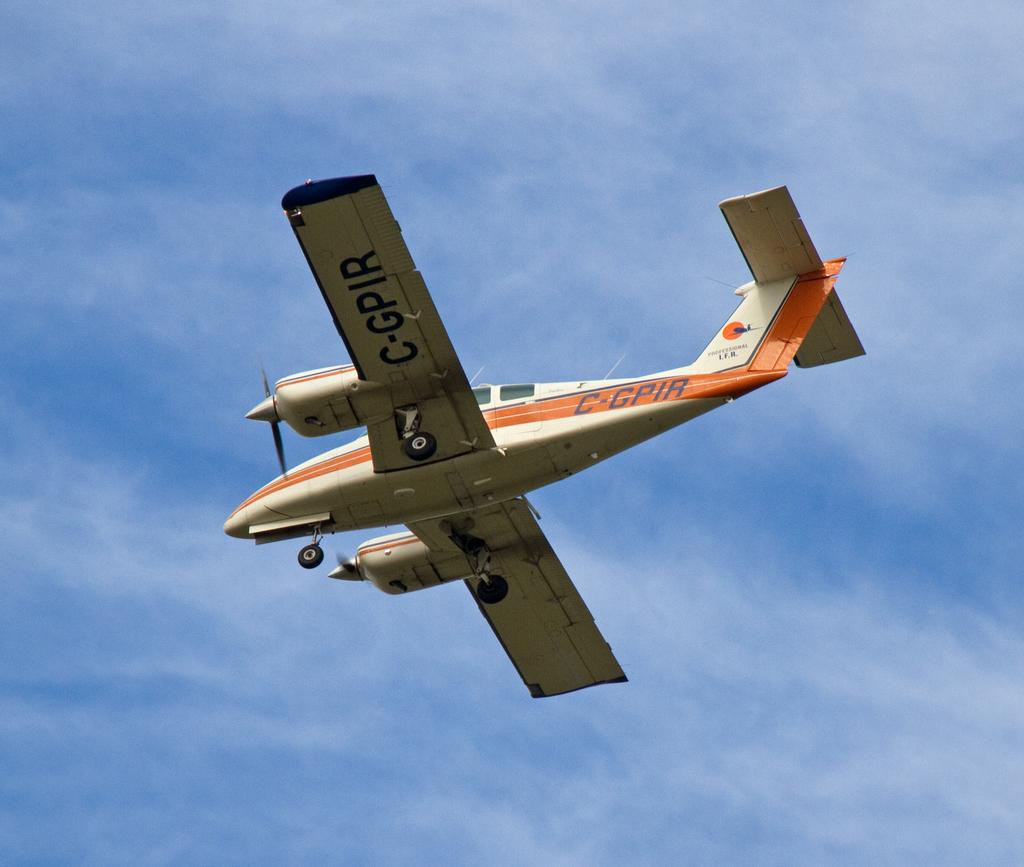What is the main subject of the picture? The main subject of the picture is an airplane. What can be seen in the background of the picture? The sky is visible in the background of the picture. What type of calculator can be seen on the wing of the airplane in the image? There is no calculator present on the wing of the airplane in the image. Can you tell me how many kittens are sitting on the tail of the airplane in the image? There are no kittens present on the tail of the airplane in the image. 